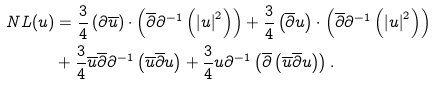Convert formula to latex. <formula><loc_0><loc_0><loc_500><loc_500>N L ( u ) & = \frac { 3 } { 4 } \left ( \partial \overline { u } \right ) \cdot \left ( \overline { \partial } \partial ^ { - 1 } \left ( \left | u \right | ^ { 2 } \right ) \right ) + \frac { 3 } { 4 } \left ( \overline { \partial } u \right ) \cdot \left ( \overline { \partial } \partial ^ { - 1 } \left ( \left | u \right | ^ { 2 } \right ) \right ) \\ & + \frac { 3 } { 4 } \overline { u } \overline { \partial } \partial ^ { - 1 } \left ( \overline { u } \overline { \partial } u \right ) + \frac { 3 } { 4 } u \partial ^ { - 1 } \left ( \overline { \partial } \left ( \overline { u } \overline { \partial } u \right ) \right ) .</formula> 